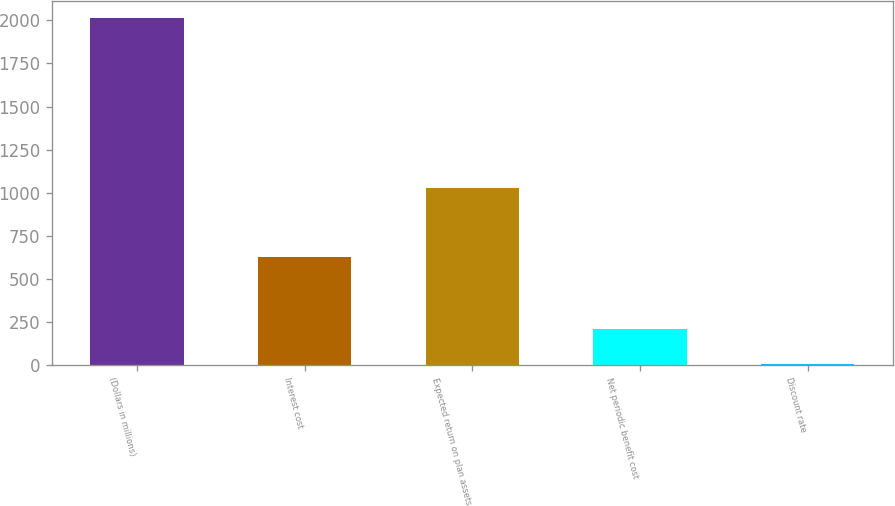<chart> <loc_0><loc_0><loc_500><loc_500><bar_chart><fcel>(Dollars in millions)<fcel>Interest cost<fcel>Expected return on plan assets<fcel>Net periodic benefit cost<fcel>Discount rate<nl><fcel>2013<fcel>623<fcel>1024<fcel>204.9<fcel>4<nl></chart> 